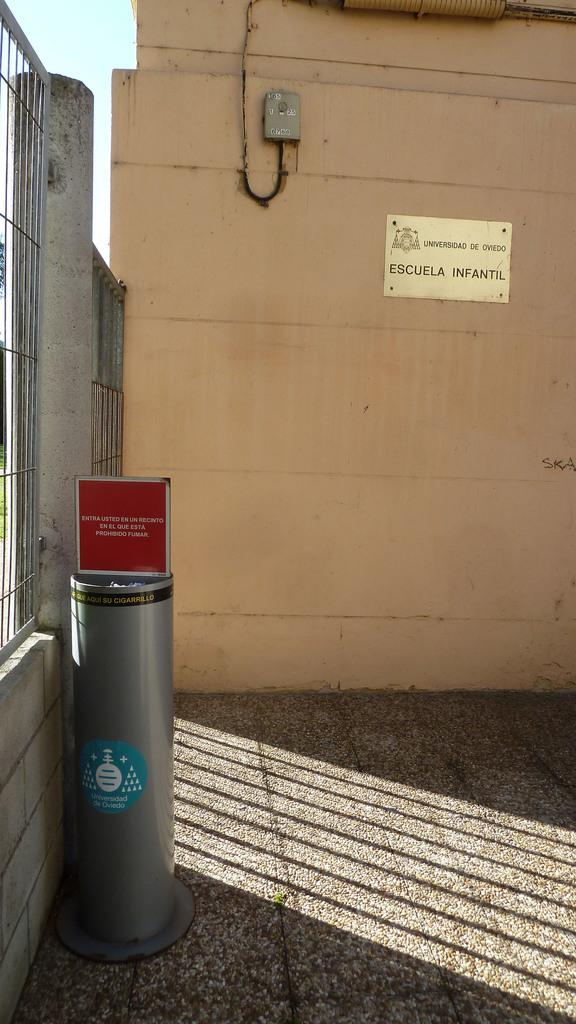<image>
Share a concise interpretation of the image provided. a sign with the word escuela on it 